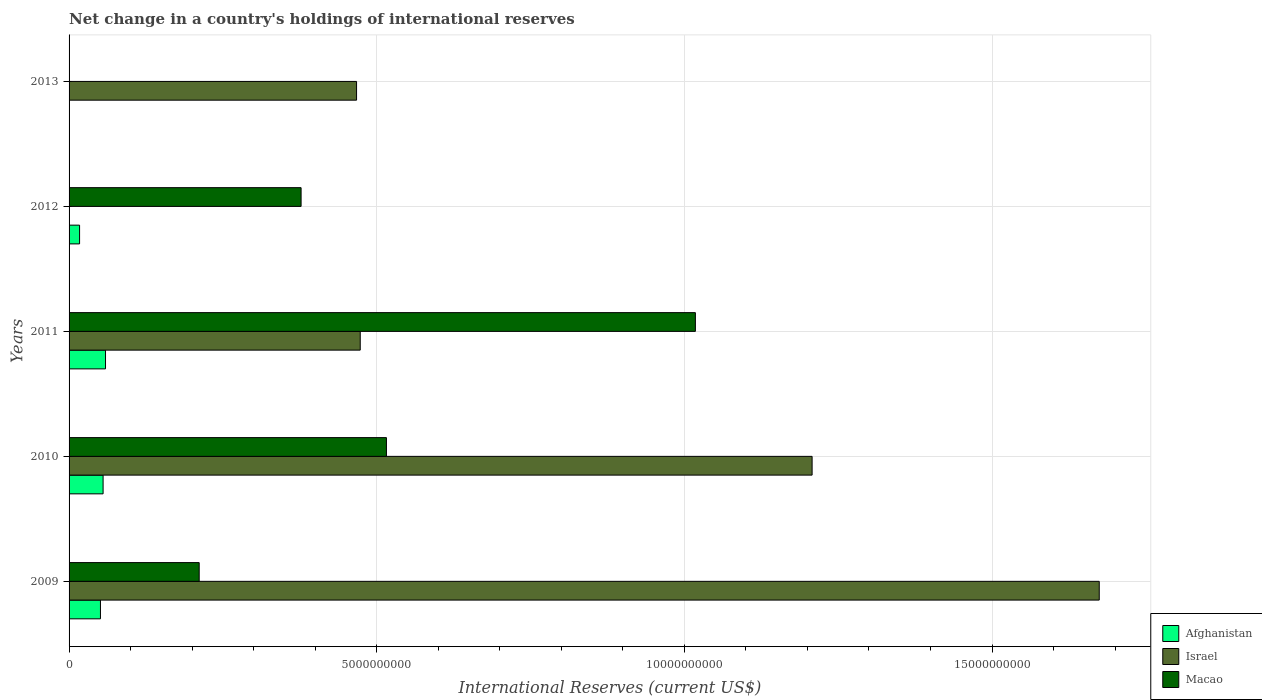Are the number of bars per tick equal to the number of legend labels?
Give a very brief answer. No. How many bars are there on the 2nd tick from the top?
Your answer should be very brief. 2. What is the label of the 1st group of bars from the top?
Keep it short and to the point. 2013. In how many cases, is the number of bars for a given year not equal to the number of legend labels?
Make the answer very short. 2. What is the international reserves in Afghanistan in 2009?
Give a very brief answer. 5.10e+08. Across all years, what is the maximum international reserves in Macao?
Keep it short and to the point. 1.02e+1. In which year was the international reserves in Afghanistan maximum?
Give a very brief answer. 2011. What is the total international reserves in Afghanistan in the graph?
Your response must be concise. 1.83e+09. What is the difference between the international reserves in Afghanistan in 2010 and that in 2011?
Provide a short and direct response. -3.93e+07. What is the difference between the international reserves in Afghanistan in 2010 and the international reserves in Israel in 2012?
Offer a terse response. 5.53e+08. What is the average international reserves in Israel per year?
Make the answer very short. 7.64e+09. In the year 2010, what is the difference between the international reserves in Macao and international reserves in Afghanistan?
Provide a short and direct response. 4.60e+09. In how many years, is the international reserves in Israel greater than 5000000000 US$?
Your answer should be compact. 2. What is the ratio of the international reserves in Afghanistan in 2010 to that in 2012?
Provide a short and direct response. 3.24. Is the international reserves in Afghanistan in 2010 less than that in 2012?
Provide a short and direct response. No. Is the difference between the international reserves in Macao in 2010 and 2012 greater than the difference between the international reserves in Afghanistan in 2010 and 2012?
Your answer should be compact. Yes. What is the difference between the highest and the second highest international reserves in Afghanistan?
Give a very brief answer. 3.93e+07. What is the difference between the highest and the lowest international reserves in Israel?
Offer a terse response. 1.67e+1. Is the sum of the international reserves in Afghanistan in 2011 and 2012 greater than the maximum international reserves in Israel across all years?
Keep it short and to the point. No. Is it the case that in every year, the sum of the international reserves in Israel and international reserves in Macao is greater than the international reserves in Afghanistan?
Offer a terse response. Yes. How many bars are there?
Your answer should be very brief. 12. What is the difference between two consecutive major ticks on the X-axis?
Your response must be concise. 5.00e+09. What is the title of the graph?
Your answer should be very brief. Net change in a country's holdings of international reserves. Does "Low income" appear as one of the legend labels in the graph?
Offer a very short reply. No. What is the label or title of the X-axis?
Provide a succinct answer. International Reserves (current US$). What is the International Reserves (current US$) of Afghanistan in 2009?
Your answer should be compact. 5.10e+08. What is the International Reserves (current US$) of Israel in 2009?
Provide a short and direct response. 1.67e+1. What is the International Reserves (current US$) of Macao in 2009?
Provide a short and direct response. 2.11e+09. What is the International Reserves (current US$) in Afghanistan in 2010?
Provide a short and direct response. 5.53e+08. What is the International Reserves (current US$) in Israel in 2010?
Your answer should be very brief. 1.21e+1. What is the International Reserves (current US$) of Macao in 2010?
Your response must be concise. 5.16e+09. What is the International Reserves (current US$) in Afghanistan in 2011?
Your answer should be compact. 5.92e+08. What is the International Reserves (current US$) of Israel in 2011?
Keep it short and to the point. 4.73e+09. What is the International Reserves (current US$) in Macao in 2011?
Ensure brevity in your answer.  1.02e+1. What is the International Reserves (current US$) of Afghanistan in 2012?
Your answer should be compact. 1.71e+08. What is the International Reserves (current US$) in Israel in 2012?
Provide a succinct answer. 0. What is the International Reserves (current US$) of Macao in 2012?
Your answer should be compact. 3.77e+09. What is the International Reserves (current US$) in Afghanistan in 2013?
Provide a short and direct response. 0. What is the International Reserves (current US$) in Israel in 2013?
Offer a very short reply. 4.67e+09. What is the International Reserves (current US$) of Macao in 2013?
Your answer should be compact. 0. Across all years, what is the maximum International Reserves (current US$) of Afghanistan?
Keep it short and to the point. 5.92e+08. Across all years, what is the maximum International Reserves (current US$) in Israel?
Your answer should be compact. 1.67e+1. Across all years, what is the maximum International Reserves (current US$) in Macao?
Offer a terse response. 1.02e+1. What is the total International Reserves (current US$) of Afghanistan in the graph?
Ensure brevity in your answer.  1.83e+09. What is the total International Reserves (current US$) of Israel in the graph?
Offer a terse response. 3.82e+1. What is the total International Reserves (current US$) of Macao in the graph?
Your response must be concise. 2.12e+1. What is the difference between the International Reserves (current US$) of Afghanistan in 2009 and that in 2010?
Offer a terse response. -4.28e+07. What is the difference between the International Reserves (current US$) in Israel in 2009 and that in 2010?
Your response must be concise. 4.67e+09. What is the difference between the International Reserves (current US$) of Macao in 2009 and that in 2010?
Ensure brevity in your answer.  -3.04e+09. What is the difference between the International Reserves (current US$) in Afghanistan in 2009 and that in 2011?
Your answer should be compact. -8.21e+07. What is the difference between the International Reserves (current US$) in Israel in 2009 and that in 2011?
Your response must be concise. 1.20e+1. What is the difference between the International Reserves (current US$) in Macao in 2009 and that in 2011?
Ensure brevity in your answer.  -8.06e+09. What is the difference between the International Reserves (current US$) in Afghanistan in 2009 and that in 2012?
Keep it short and to the point. 3.39e+08. What is the difference between the International Reserves (current US$) of Macao in 2009 and that in 2012?
Make the answer very short. -1.66e+09. What is the difference between the International Reserves (current US$) in Israel in 2009 and that in 2013?
Offer a very short reply. 1.21e+1. What is the difference between the International Reserves (current US$) in Afghanistan in 2010 and that in 2011?
Provide a short and direct response. -3.93e+07. What is the difference between the International Reserves (current US$) of Israel in 2010 and that in 2011?
Offer a terse response. 7.34e+09. What is the difference between the International Reserves (current US$) of Macao in 2010 and that in 2011?
Ensure brevity in your answer.  -5.02e+09. What is the difference between the International Reserves (current US$) of Afghanistan in 2010 and that in 2012?
Offer a very short reply. 3.82e+08. What is the difference between the International Reserves (current US$) of Macao in 2010 and that in 2012?
Keep it short and to the point. 1.39e+09. What is the difference between the International Reserves (current US$) in Israel in 2010 and that in 2013?
Make the answer very short. 7.40e+09. What is the difference between the International Reserves (current US$) in Afghanistan in 2011 and that in 2012?
Keep it short and to the point. 4.22e+08. What is the difference between the International Reserves (current US$) of Macao in 2011 and that in 2012?
Give a very brief answer. 6.41e+09. What is the difference between the International Reserves (current US$) in Israel in 2011 and that in 2013?
Your response must be concise. 5.98e+07. What is the difference between the International Reserves (current US$) of Afghanistan in 2009 and the International Reserves (current US$) of Israel in 2010?
Your response must be concise. -1.16e+1. What is the difference between the International Reserves (current US$) of Afghanistan in 2009 and the International Reserves (current US$) of Macao in 2010?
Keep it short and to the point. -4.65e+09. What is the difference between the International Reserves (current US$) of Israel in 2009 and the International Reserves (current US$) of Macao in 2010?
Your answer should be very brief. 1.16e+1. What is the difference between the International Reserves (current US$) in Afghanistan in 2009 and the International Reserves (current US$) in Israel in 2011?
Offer a very short reply. -4.22e+09. What is the difference between the International Reserves (current US$) in Afghanistan in 2009 and the International Reserves (current US$) in Macao in 2011?
Provide a succinct answer. -9.67e+09. What is the difference between the International Reserves (current US$) in Israel in 2009 and the International Reserves (current US$) in Macao in 2011?
Your answer should be compact. 6.56e+09. What is the difference between the International Reserves (current US$) of Afghanistan in 2009 and the International Reserves (current US$) of Macao in 2012?
Offer a terse response. -3.26e+09. What is the difference between the International Reserves (current US$) of Israel in 2009 and the International Reserves (current US$) of Macao in 2012?
Your response must be concise. 1.30e+1. What is the difference between the International Reserves (current US$) in Afghanistan in 2009 and the International Reserves (current US$) in Israel in 2013?
Your answer should be compact. -4.16e+09. What is the difference between the International Reserves (current US$) of Afghanistan in 2010 and the International Reserves (current US$) of Israel in 2011?
Give a very brief answer. -4.18e+09. What is the difference between the International Reserves (current US$) in Afghanistan in 2010 and the International Reserves (current US$) in Macao in 2011?
Keep it short and to the point. -9.63e+09. What is the difference between the International Reserves (current US$) of Israel in 2010 and the International Reserves (current US$) of Macao in 2011?
Provide a short and direct response. 1.90e+09. What is the difference between the International Reserves (current US$) in Afghanistan in 2010 and the International Reserves (current US$) in Macao in 2012?
Provide a short and direct response. -3.22e+09. What is the difference between the International Reserves (current US$) in Israel in 2010 and the International Reserves (current US$) in Macao in 2012?
Give a very brief answer. 8.30e+09. What is the difference between the International Reserves (current US$) in Afghanistan in 2010 and the International Reserves (current US$) in Israel in 2013?
Provide a short and direct response. -4.12e+09. What is the difference between the International Reserves (current US$) of Afghanistan in 2011 and the International Reserves (current US$) of Macao in 2012?
Ensure brevity in your answer.  -3.18e+09. What is the difference between the International Reserves (current US$) in Israel in 2011 and the International Reserves (current US$) in Macao in 2012?
Provide a succinct answer. 9.61e+08. What is the difference between the International Reserves (current US$) of Afghanistan in 2011 and the International Reserves (current US$) of Israel in 2013?
Keep it short and to the point. -4.08e+09. What is the difference between the International Reserves (current US$) in Afghanistan in 2012 and the International Reserves (current US$) in Israel in 2013?
Provide a succinct answer. -4.50e+09. What is the average International Reserves (current US$) of Afghanistan per year?
Offer a terse response. 3.65e+08. What is the average International Reserves (current US$) in Israel per year?
Provide a short and direct response. 7.64e+09. What is the average International Reserves (current US$) in Macao per year?
Keep it short and to the point. 4.24e+09. In the year 2009, what is the difference between the International Reserves (current US$) of Afghanistan and International Reserves (current US$) of Israel?
Give a very brief answer. -1.62e+1. In the year 2009, what is the difference between the International Reserves (current US$) of Afghanistan and International Reserves (current US$) of Macao?
Offer a very short reply. -1.60e+09. In the year 2009, what is the difference between the International Reserves (current US$) in Israel and International Reserves (current US$) in Macao?
Provide a short and direct response. 1.46e+1. In the year 2010, what is the difference between the International Reserves (current US$) of Afghanistan and International Reserves (current US$) of Israel?
Your response must be concise. -1.15e+1. In the year 2010, what is the difference between the International Reserves (current US$) of Afghanistan and International Reserves (current US$) of Macao?
Make the answer very short. -4.60e+09. In the year 2010, what is the difference between the International Reserves (current US$) of Israel and International Reserves (current US$) of Macao?
Keep it short and to the point. 6.92e+09. In the year 2011, what is the difference between the International Reserves (current US$) of Afghanistan and International Reserves (current US$) of Israel?
Offer a very short reply. -4.14e+09. In the year 2011, what is the difference between the International Reserves (current US$) in Afghanistan and International Reserves (current US$) in Macao?
Make the answer very short. -9.59e+09. In the year 2011, what is the difference between the International Reserves (current US$) of Israel and International Reserves (current US$) of Macao?
Offer a very short reply. -5.45e+09. In the year 2012, what is the difference between the International Reserves (current US$) of Afghanistan and International Reserves (current US$) of Macao?
Ensure brevity in your answer.  -3.60e+09. What is the ratio of the International Reserves (current US$) of Afghanistan in 2009 to that in 2010?
Keep it short and to the point. 0.92. What is the ratio of the International Reserves (current US$) in Israel in 2009 to that in 2010?
Your answer should be very brief. 1.39. What is the ratio of the International Reserves (current US$) of Macao in 2009 to that in 2010?
Give a very brief answer. 0.41. What is the ratio of the International Reserves (current US$) of Afghanistan in 2009 to that in 2011?
Offer a very short reply. 0.86. What is the ratio of the International Reserves (current US$) in Israel in 2009 to that in 2011?
Ensure brevity in your answer.  3.54. What is the ratio of the International Reserves (current US$) in Macao in 2009 to that in 2011?
Your answer should be compact. 0.21. What is the ratio of the International Reserves (current US$) of Afghanistan in 2009 to that in 2012?
Make the answer very short. 2.99. What is the ratio of the International Reserves (current US$) in Macao in 2009 to that in 2012?
Your response must be concise. 0.56. What is the ratio of the International Reserves (current US$) in Israel in 2009 to that in 2013?
Offer a very short reply. 3.58. What is the ratio of the International Reserves (current US$) in Afghanistan in 2010 to that in 2011?
Offer a terse response. 0.93. What is the ratio of the International Reserves (current US$) of Israel in 2010 to that in 2011?
Give a very brief answer. 2.55. What is the ratio of the International Reserves (current US$) of Macao in 2010 to that in 2011?
Your answer should be very brief. 0.51. What is the ratio of the International Reserves (current US$) in Afghanistan in 2010 to that in 2012?
Make the answer very short. 3.24. What is the ratio of the International Reserves (current US$) of Macao in 2010 to that in 2012?
Give a very brief answer. 1.37. What is the ratio of the International Reserves (current US$) of Israel in 2010 to that in 2013?
Your response must be concise. 2.58. What is the ratio of the International Reserves (current US$) in Afghanistan in 2011 to that in 2012?
Provide a short and direct response. 3.47. What is the ratio of the International Reserves (current US$) of Macao in 2011 to that in 2012?
Keep it short and to the point. 2.7. What is the ratio of the International Reserves (current US$) of Israel in 2011 to that in 2013?
Your answer should be compact. 1.01. What is the difference between the highest and the second highest International Reserves (current US$) of Afghanistan?
Give a very brief answer. 3.93e+07. What is the difference between the highest and the second highest International Reserves (current US$) of Israel?
Make the answer very short. 4.67e+09. What is the difference between the highest and the second highest International Reserves (current US$) in Macao?
Offer a very short reply. 5.02e+09. What is the difference between the highest and the lowest International Reserves (current US$) in Afghanistan?
Ensure brevity in your answer.  5.92e+08. What is the difference between the highest and the lowest International Reserves (current US$) of Israel?
Offer a terse response. 1.67e+1. What is the difference between the highest and the lowest International Reserves (current US$) of Macao?
Provide a succinct answer. 1.02e+1. 